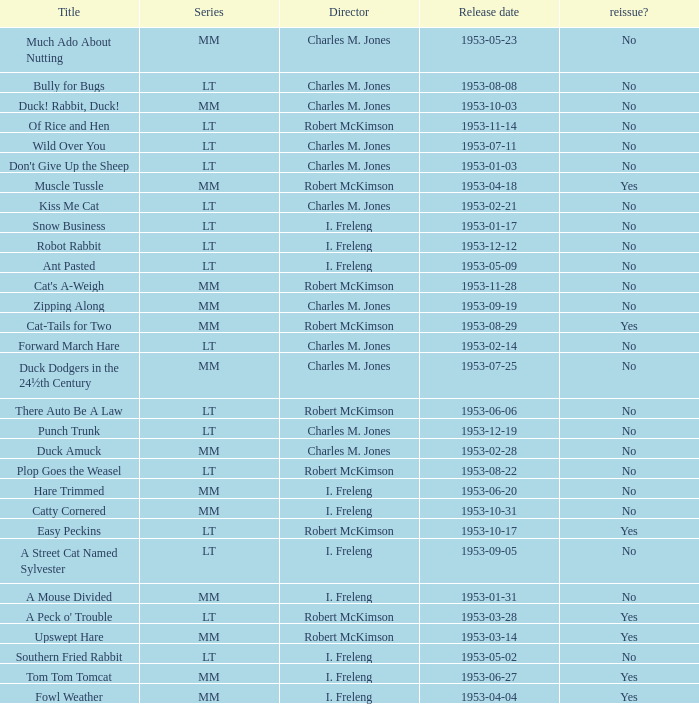Help me parse the entirety of this table. {'header': ['Title', 'Series', 'Director', 'Release date', 'reissue?'], 'rows': [['Much Ado About Nutting', 'MM', 'Charles M. Jones', '1953-05-23', 'No'], ['Bully for Bugs', 'LT', 'Charles M. Jones', '1953-08-08', 'No'], ['Duck! Rabbit, Duck!', 'MM', 'Charles M. Jones', '1953-10-03', 'No'], ['Of Rice and Hen', 'LT', 'Robert McKimson', '1953-11-14', 'No'], ['Wild Over You', 'LT', 'Charles M. Jones', '1953-07-11', 'No'], ["Don't Give Up the Sheep", 'LT', 'Charles M. Jones', '1953-01-03', 'No'], ['Muscle Tussle', 'MM', 'Robert McKimson', '1953-04-18', 'Yes'], ['Kiss Me Cat', 'LT', 'Charles M. Jones', '1953-02-21', 'No'], ['Snow Business', 'LT', 'I. Freleng', '1953-01-17', 'No'], ['Robot Rabbit', 'LT', 'I. Freleng', '1953-12-12', 'No'], ['Ant Pasted', 'LT', 'I. Freleng', '1953-05-09', 'No'], ["Cat's A-Weigh", 'MM', 'Robert McKimson', '1953-11-28', 'No'], ['Zipping Along', 'MM', 'Charles M. Jones', '1953-09-19', 'No'], ['Cat-Tails for Two', 'MM', 'Robert McKimson', '1953-08-29', 'Yes'], ['Forward March Hare', 'LT', 'Charles M. Jones', '1953-02-14', 'No'], ['Duck Dodgers in the 24½th Century', 'MM', 'Charles M. Jones', '1953-07-25', 'No'], ['There Auto Be A Law', 'LT', 'Robert McKimson', '1953-06-06', 'No'], ['Punch Trunk', 'LT', 'Charles M. Jones', '1953-12-19', 'No'], ['Duck Amuck', 'MM', 'Charles M. Jones', '1953-02-28', 'No'], ['Plop Goes the Weasel', 'LT', 'Robert McKimson', '1953-08-22', 'No'], ['Hare Trimmed', 'MM', 'I. Freleng', '1953-06-20', 'No'], ['Catty Cornered', 'MM', 'I. Freleng', '1953-10-31', 'No'], ['Easy Peckins', 'LT', 'Robert McKimson', '1953-10-17', 'Yes'], ['A Street Cat Named Sylvester', 'LT', 'I. Freleng', '1953-09-05', 'No'], ['A Mouse Divided', 'MM', 'I. Freleng', '1953-01-31', 'No'], ["A Peck o' Trouble", 'LT', 'Robert McKimson', '1953-03-28', 'Yes'], ['Upswept Hare', 'MM', 'Robert McKimson', '1953-03-14', 'Yes'], ['Southern Fried Rabbit', 'LT', 'I. Freleng', '1953-05-02', 'No'], ['Tom Tom Tomcat', 'MM', 'I. Freleng', '1953-06-27', 'Yes'], ['Fowl Weather', 'MM', 'I. Freleng', '1953-04-04', 'Yes']]} What's the release date of Forward March Hare? 1953-02-14. 